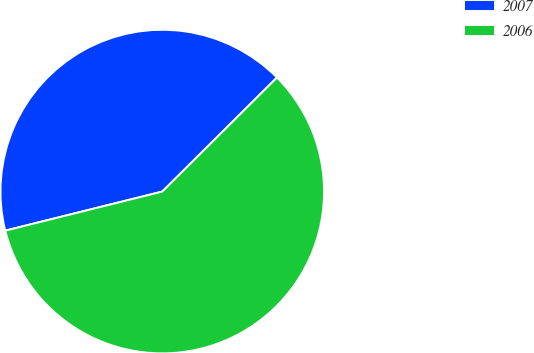<chart> <loc_0><loc_0><loc_500><loc_500><pie_chart><fcel>2007<fcel>2006<nl><fcel>41.43%<fcel>58.57%<nl></chart> 